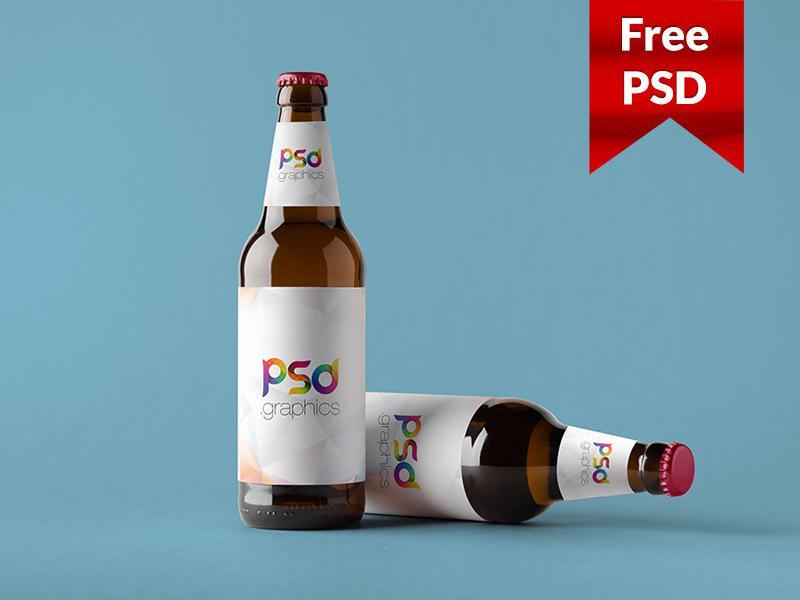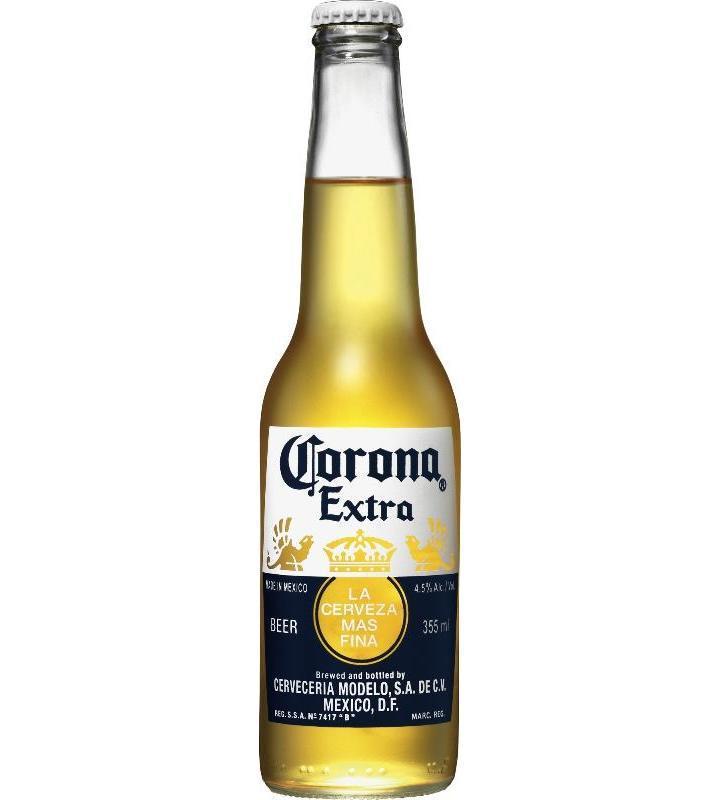The first image is the image on the left, the second image is the image on the right. Assess this claim about the two images: "There are no less than three beer bottles". Correct or not? Answer yes or no. Yes. The first image is the image on the left, the second image is the image on the right. Assess this claim about the two images: "There are two glass beer bottles". Correct or not? Answer yes or no. No. The first image is the image on the left, the second image is the image on the right. Analyze the images presented: Is the assertion "At least two beer bottles have labels on body and neck of the bottle, and exactly one bottle has just a body label." valid? Answer yes or no. Yes. The first image is the image on the left, the second image is the image on the right. Examine the images to the left and right. Is the description "there are at least two bottles in the image on the left" accurate? Answer yes or no. Yes. 